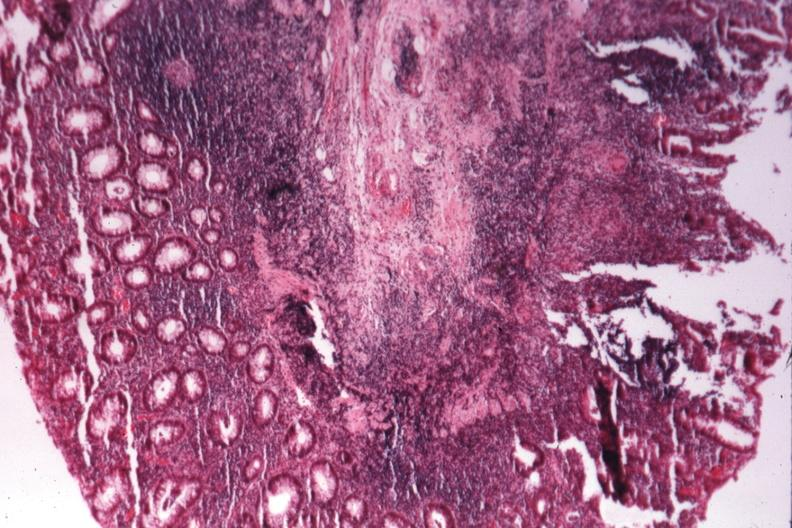does cachexia show source of granulomatous colitis?
Answer the question using a single word or phrase. No 